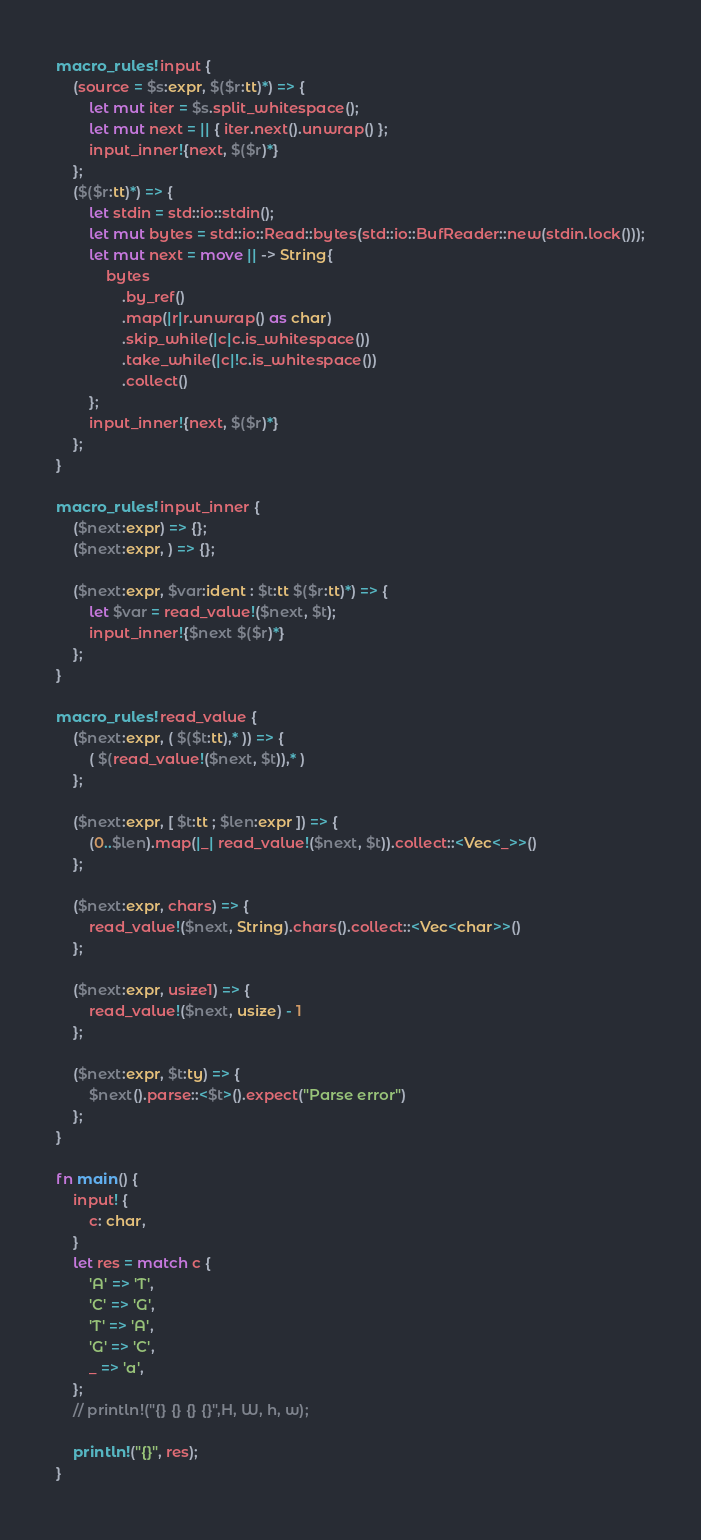<code> <loc_0><loc_0><loc_500><loc_500><_Rust_>macro_rules! input {
    (source = $s:expr, $($r:tt)*) => {
        let mut iter = $s.split_whitespace();
        let mut next = || { iter.next().unwrap() };
        input_inner!{next, $($r)*}
    };
    ($($r:tt)*) => {
        let stdin = std::io::stdin();
        let mut bytes = std::io::Read::bytes(std::io::BufReader::new(stdin.lock()));
        let mut next = move || -> String{
            bytes
                .by_ref()
                .map(|r|r.unwrap() as char)
                .skip_while(|c|c.is_whitespace())
                .take_while(|c|!c.is_whitespace())
                .collect()
        };
        input_inner!{next, $($r)*}
    };
}

macro_rules! input_inner {
    ($next:expr) => {};
    ($next:expr, ) => {};

    ($next:expr, $var:ident : $t:tt $($r:tt)*) => {
        let $var = read_value!($next, $t);
        input_inner!{$next $($r)*}
    };
}

macro_rules! read_value {
    ($next:expr, ( $($t:tt),* )) => {
        ( $(read_value!($next, $t)),* )
    };

    ($next:expr, [ $t:tt ; $len:expr ]) => {
        (0..$len).map(|_| read_value!($next, $t)).collect::<Vec<_>>()
    };

    ($next:expr, chars) => {
        read_value!($next, String).chars().collect::<Vec<char>>()
    };

    ($next:expr, usize1) => {
        read_value!($next, usize) - 1
    };

    ($next:expr, $t:ty) => {
        $next().parse::<$t>().expect("Parse error")
    };
}

fn main() {
    input! {
        c: char,
    }
    let res = match c {
        'A' => 'T',
        'C' => 'G',
        'T' => 'A',
        'G' => 'C',
        _ => 'a',
    };
    // println!("{} {} {} {}",H, W, h, w);

    println!("{}", res);
}
</code> 